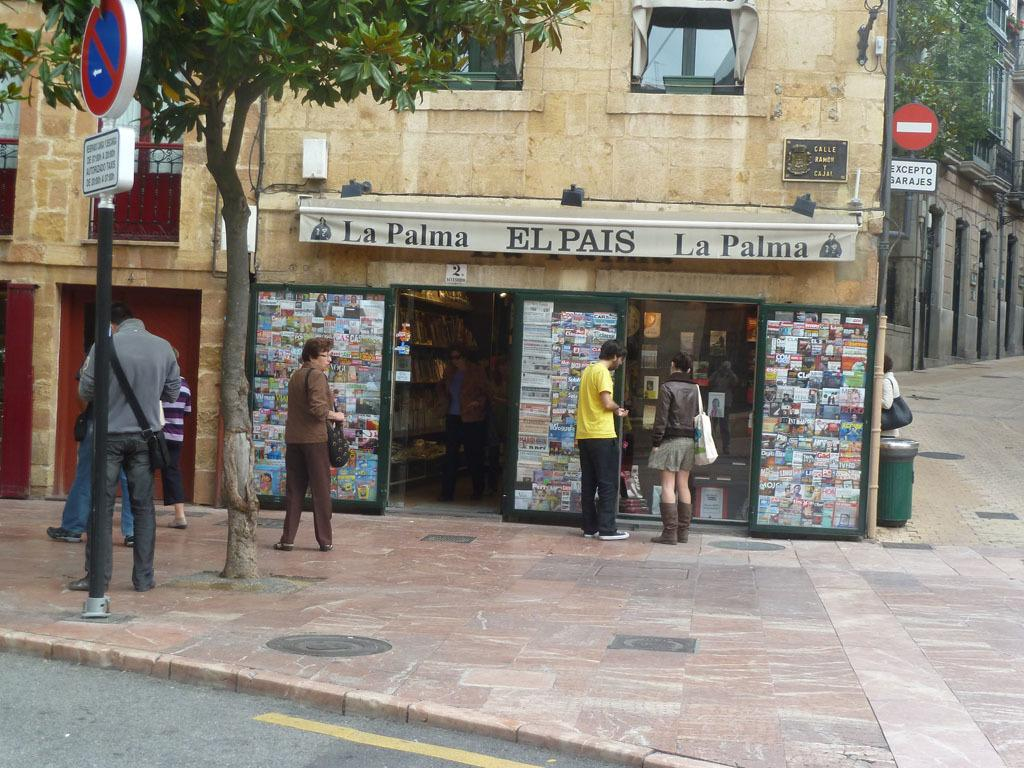What type of structure can be seen in the image? There is a building in the image. Are there any people present in the image? Yes, there are people in the image. What other objects can be seen in the image besides the building and people? There are poles, boards, a road, a footpath, a tree, books, and other objects in the image. How many jellyfish can be seen swimming in the water in the image? There are no jellyfish or water present in the image; it features a building, people, and various objects on land. What type of lace is used to decorate the tree in the image? There is no lace used to decorate the tree in the image; it is a natural tree with no decorations. 